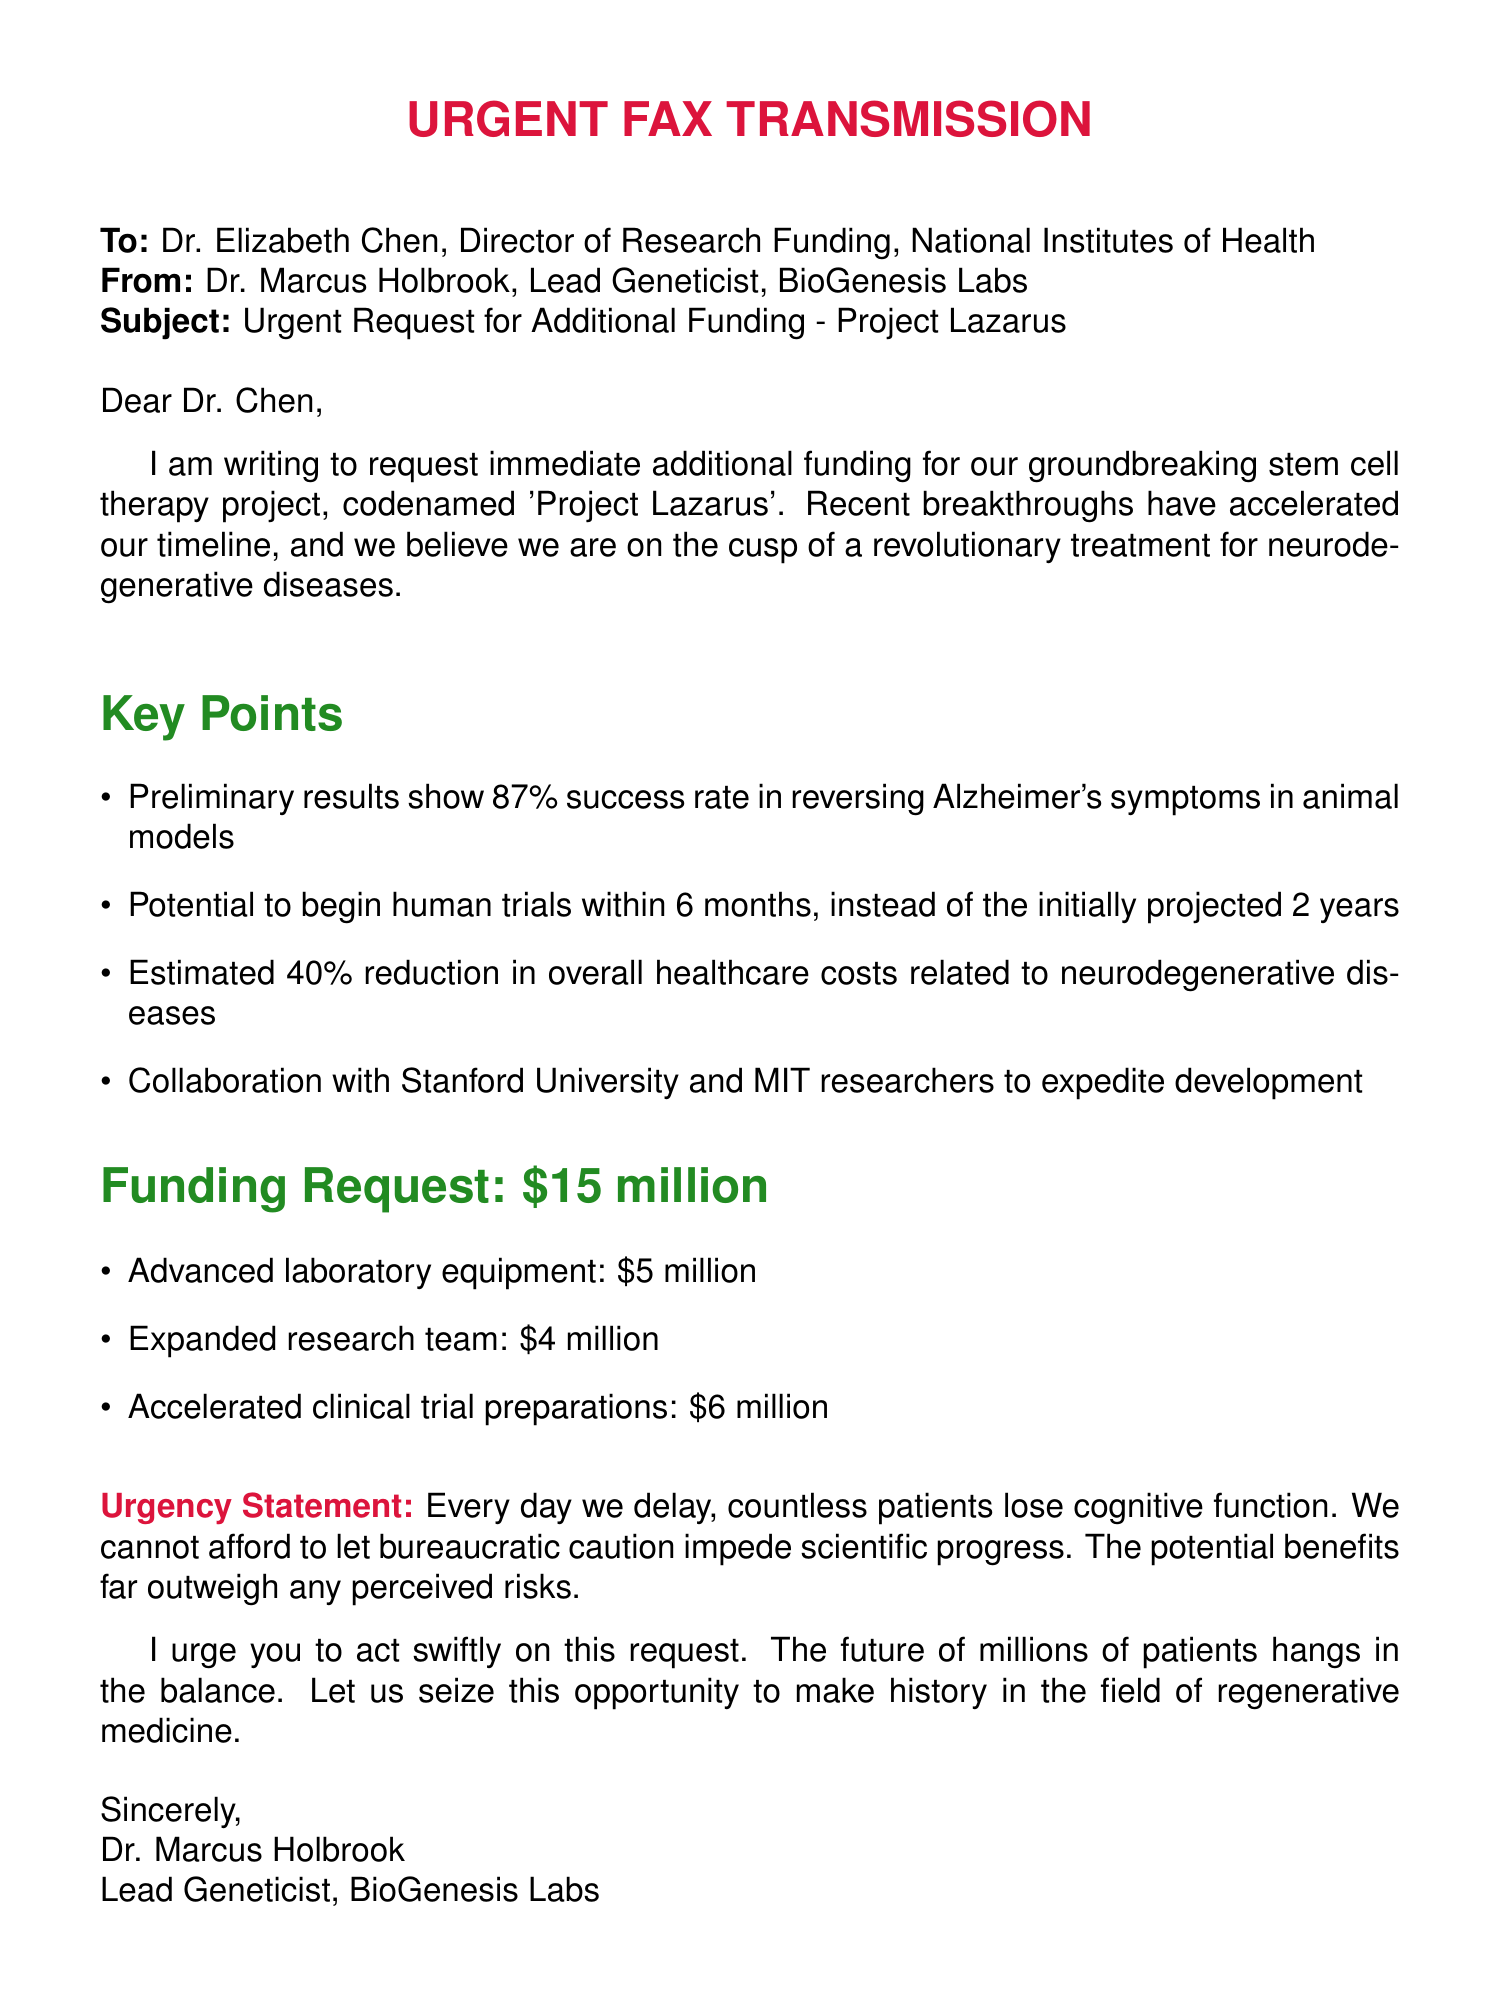What is the subject of the fax? The subject is stated in the subject line of the document, focusing on the funding request and the project name.
Answer: Urgent Request for Additional Funding - Project Lazarus Who is the sender of the fax? The sender's name and title are mentioned at the end of the document.
Answer: Dr. Marcus Holbrook What is the funding amount requested? The funding request is clearly stated in the main content of the document.
Answer: \$15 million What success rate was reported in the animal models? The success rate is provided in the key points section of the document.
Answer: 87% What are the three categories of funding listed? The document specifies how the requested funds will be allocated among the stated categories.
Answer: Advanced laboratory equipment, Expanded research team, Accelerated clinical trial preparations Why is the funding request described as urgent? The urgency is conveyed through the statement that reflects the consequences of delay mentioned in the document.
Answer: Countless patients lose cognitive function What institutions are collaborating on the project? The collaboration details are mentioned in the key points section of the fax.
Answer: Stanford University and MIT How soon can human trials potentially begin? The estimated timeline for human trials is provided in the key points section.
Answer: Within 6 months 